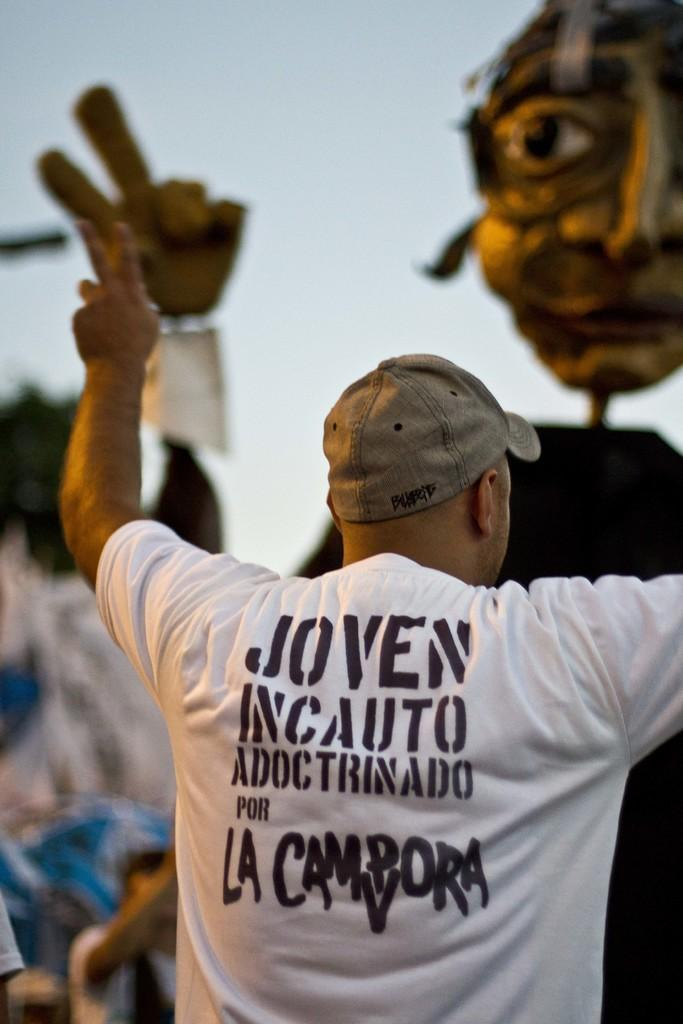What is the main subject in the foreground of the picture? There is a person in the foreground of the picture. What is the person wearing on their upper body? The person is wearing a white t-shirt. What type of headwear is the person wearing? The person is wearing a cap. Can you describe the center of the image? The center of the image is blurred. What can be seen in the background of the image? There is a mask in the background of the image. What degree does the person in the picture have? There is no information about the person's degree in the image. What type of party is being held in the background of the image? There is no party depicted in the image; only a mask is visible in the background. 